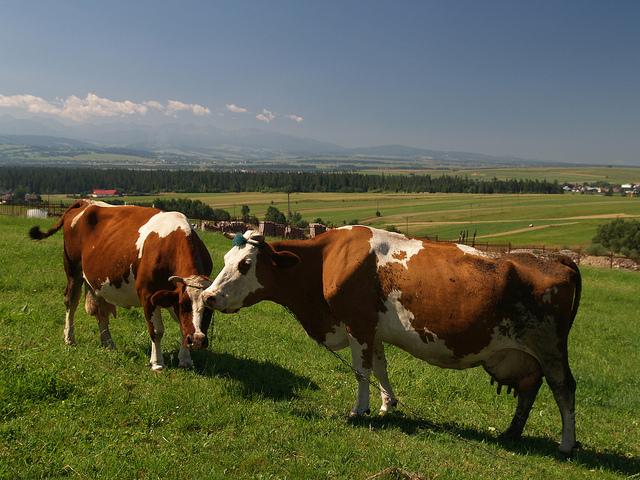What is the weather like?
Short answer required. Sunny. How many cows are present?
Quick response, please. 2. What color are the cows?
Concise answer only. Brown and white. 